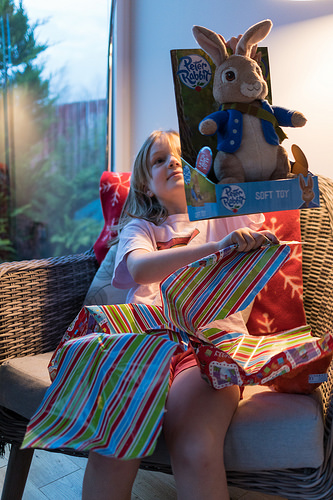<image>
Can you confirm if the chair is under the bunny? Yes. The chair is positioned underneath the bunny, with the bunny above it in the vertical space. 